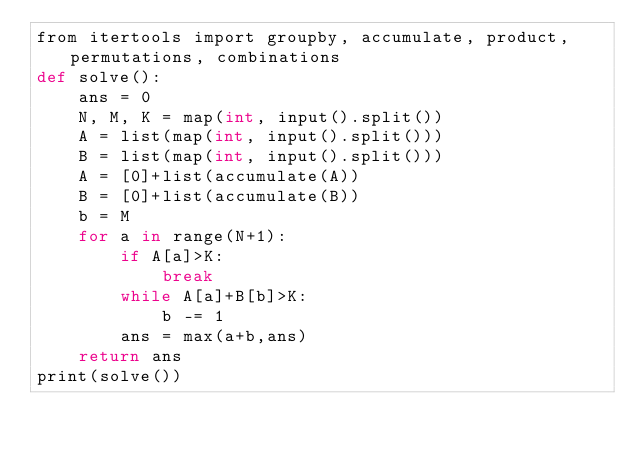Convert code to text. <code><loc_0><loc_0><loc_500><loc_500><_Cython_>from itertools import groupby, accumulate, product, permutations, combinations
def solve():
    ans = 0
    N, M, K = map(int, input().split())
    A = list(map(int, input().split()))
    B = list(map(int, input().split()))
    A = [0]+list(accumulate(A))
    B = [0]+list(accumulate(B))
    b = M
    for a in range(N+1):
        if A[a]>K:
            break
        while A[a]+B[b]>K:
            b -= 1
        ans = max(a+b,ans)
    return ans
print(solve())
</code> 